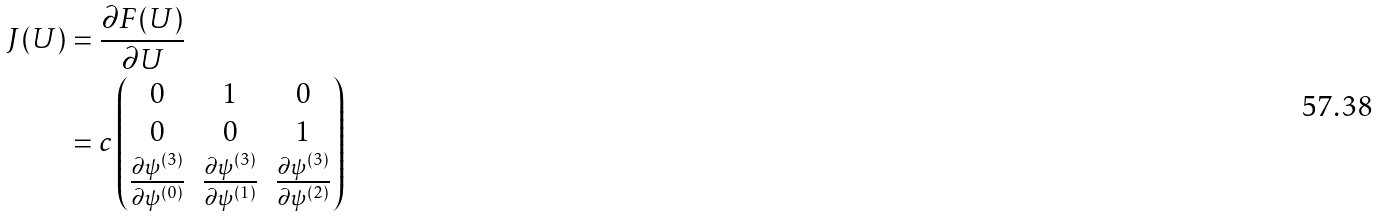<formula> <loc_0><loc_0><loc_500><loc_500>J ( U ) & = \frac { \partial F ( U ) } { \partial U } \\ & = c \left ( \begin{matrix} 0 & 1 & 0 \\ 0 & 0 & 1 \\ \frac { \partial \psi ^ { ( 3 ) } } { \partial \psi ^ { ( 0 ) } } & \frac { \partial \psi ^ { ( 3 ) } } { \partial \psi ^ { ( 1 ) } } & \frac { \partial \psi ^ { ( 3 ) } } { \partial \psi ^ { ( 2 ) } } \end{matrix} \right )</formula> 